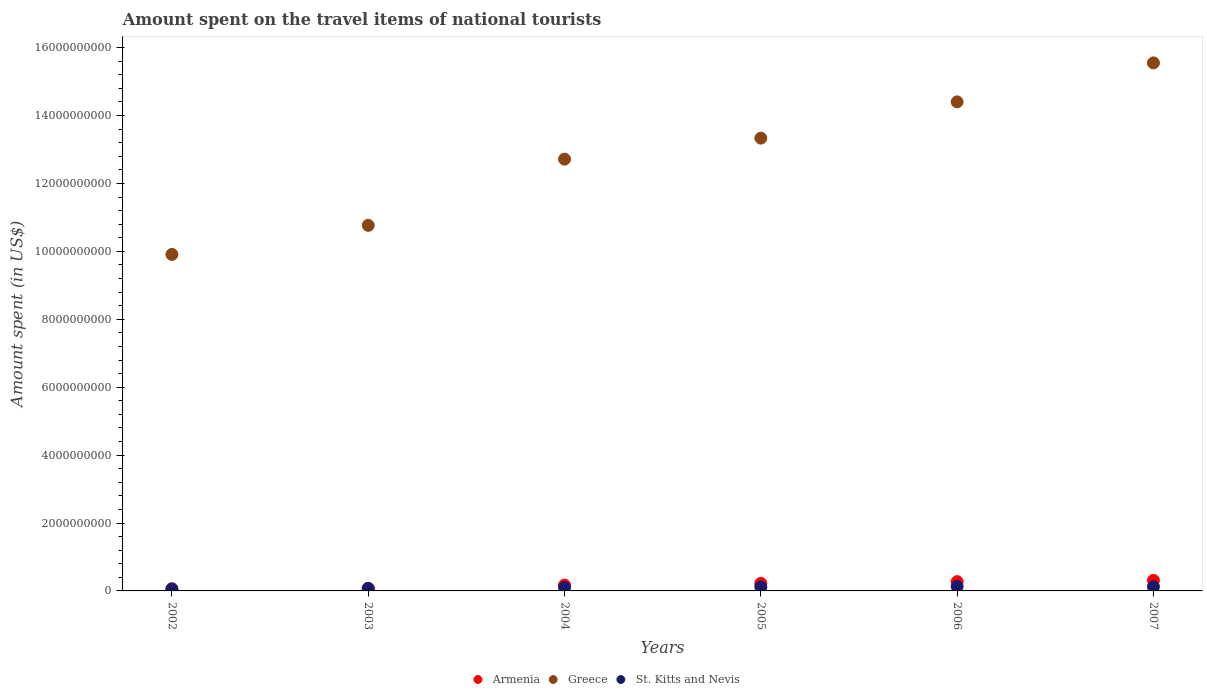How many different coloured dotlines are there?
Offer a very short reply. 3. What is the amount spent on the travel items of national tourists in Armenia in 2003?
Offer a very short reply. 7.30e+07. Across all years, what is the maximum amount spent on the travel items of national tourists in Armenia?
Offer a terse response. 3.11e+08. Across all years, what is the minimum amount spent on the travel items of national tourists in Greece?
Make the answer very short. 9.91e+09. What is the total amount spent on the travel items of national tourists in St. Kitts and Nevis in the graph?
Give a very brief answer. 6.13e+08. What is the difference between the amount spent on the travel items of national tourists in Armenia in 2002 and that in 2003?
Your response must be concise. -1.00e+07. What is the difference between the amount spent on the travel items of national tourists in Armenia in 2003 and the amount spent on the travel items of national tourists in St. Kitts and Nevis in 2007?
Offer a terse response. -5.20e+07. What is the average amount spent on the travel items of national tourists in Armenia per year?
Your answer should be compact. 1.86e+08. In the year 2003, what is the difference between the amount spent on the travel items of national tourists in St. Kitts and Nevis and amount spent on the travel items of national tourists in Armenia?
Provide a short and direct response. 2.00e+06. In how many years, is the amount spent on the travel items of national tourists in Armenia greater than 7600000000 US$?
Keep it short and to the point. 0. What is the ratio of the amount spent on the travel items of national tourists in St. Kitts and Nevis in 2003 to that in 2004?
Give a very brief answer. 0.73. Is the amount spent on the travel items of national tourists in Greece in 2006 less than that in 2007?
Offer a very short reply. Yes. Is the difference between the amount spent on the travel items of national tourists in St. Kitts and Nevis in 2003 and 2006 greater than the difference between the amount spent on the travel items of national tourists in Armenia in 2003 and 2006?
Offer a terse response. Yes. What is the difference between the highest and the second highest amount spent on the travel items of national tourists in Armenia?
Offer a very short reply. 3.80e+07. What is the difference between the highest and the lowest amount spent on the travel items of national tourists in St. Kitts and Nevis?
Give a very brief answer. 7.50e+07. In how many years, is the amount spent on the travel items of national tourists in Greece greater than the average amount spent on the travel items of national tourists in Greece taken over all years?
Provide a short and direct response. 3. Does the amount spent on the travel items of national tourists in St. Kitts and Nevis monotonically increase over the years?
Ensure brevity in your answer.  No. Is the amount spent on the travel items of national tourists in Armenia strictly greater than the amount spent on the travel items of national tourists in Greece over the years?
Offer a terse response. No. How many dotlines are there?
Offer a terse response. 3. What is the difference between two consecutive major ticks on the Y-axis?
Ensure brevity in your answer.  2.00e+09. Are the values on the major ticks of Y-axis written in scientific E-notation?
Offer a very short reply. No. Does the graph contain any zero values?
Your answer should be very brief. No. Does the graph contain grids?
Provide a succinct answer. No. How are the legend labels stacked?
Provide a short and direct response. Horizontal. What is the title of the graph?
Offer a terse response. Amount spent on the travel items of national tourists. Does "Maldives" appear as one of the legend labels in the graph?
Provide a short and direct response. No. What is the label or title of the X-axis?
Your response must be concise. Years. What is the label or title of the Y-axis?
Give a very brief answer. Amount spent (in US$). What is the Amount spent (in US$) in Armenia in 2002?
Keep it short and to the point. 6.30e+07. What is the Amount spent (in US$) in Greece in 2002?
Ensure brevity in your answer.  9.91e+09. What is the Amount spent (in US$) in St. Kitts and Nevis in 2002?
Your answer should be very brief. 5.70e+07. What is the Amount spent (in US$) in Armenia in 2003?
Keep it short and to the point. 7.30e+07. What is the Amount spent (in US$) in Greece in 2003?
Provide a succinct answer. 1.08e+1. What is the Amount spent (in US$) in St. Kitts and Nevis in 2003?
Offer a very short reply. 7.50e+07. What is the Amount spent (in US$) of Armenia in 2004?
Offer a terse response. 1.71e+08. What is the Amount spent (in US$) of Greece in 2004?
Your answer should be very brief. 1.27e+1. What is the Amount spent (in US$) in St. Kitts and Nevis in 2004?
Offer a terse response. 1.03e+08. What is the Amount spent (in US$) of Armenia in 2005?
Your response must be concise. 2.23e+08. What is the Amount spent (in US$) of Greece in 2005?
Provide a short and direct response. 1.33e+1. What is the Amount spent (in US$) in St. Kitts and Nevis in 2005?
Offer a terse response. 1.21e+08. What is the Amount spent (in US$) of Armenia in 2006?
Provide a short and direct response. 2.73e+08. What is the Amount spent (in US$) of Greece in 2006?
Offer a very short reply. 1.44e+1. What is the Amount spent (in US$) of St. Kitts and Nevis in 2006?
Offer a very short reply. 1.32e+08. What is the Amount spent (in US$) in Armenia in 2007?
Offer a terse response. 3.11e+08. What is the Amount spent (in US$) in Greece in 2007?
Your answer should be very brief. 1.56e+1. What is the Amount spent (in US$) in St. Kitts and Nevis in 2007?
Your answer should be compact. 1.25e+08. Across all years, what is the maximum Amount spent (in US$) in Armenia?
Give a very brief answer. 3.11e+08. Across all years, what is the maximum Amount spent (in US$) in Greece?
Give a very brief answer. 1.56e+1. Across all years, what is the maximum Amount spent (in US$) of St. Kitts and Nevis?
Provide a succinct answer. 1.32e+08. Across all years, what is the minimum Amount spent (in US$) of Armenia?
Your response must be concise. 6.30e+07. Across all years, what is the minimum Amount spent (in US$) of Greece?
Offer a terse response. 9.91e+09. Across all years, what is the minimum Amount spent (in US$) in St. Kitts and Nevis?
Offer a terse response. 5.70e+07. What is the total Amount spent (in US$) in Armenia in the graph?
Provide a short and direct response. 1.11e+09. What is the total Amount spent (in US$) of Greece in the graph?
Give a very brief answer. 7.67e+1. What is the total Amount spent (in US$) in St. Kitts and Nevis in the graph?
Your answer should be compact. 6.13e+08. What is the difference between the Amount spent (in US$) of Armenia in 2002 and that in 2003?
Your answer should be very brief. -1.00e+07. What is the difference between the Amount spent (in US$) of Greece in 2002 and that in 2003?
Your answer should be compact. -8.57e+08. What is the difference between the Amount spent (in US$) in St. Kitts and Nevis in 2002 and that in 2003?
Offer a very short reply. -1.80e+07. What is the difference between the Amount spent (in US$) in Armenia in 2002 and that in 2004?
Offer a terse response. -1.08e+08. What is the difference between the Amount spent (in US$) of Greece in 2002 and that in 2004?
Provide a short and direct response. -2.81e+09. What is the difference between the Amount spent (in US$) in St. Kitts and Nevis in 2002 and that in 2004?
Provide a short and direct response. -4.60e+07. What is the difference between the Amount spent (in US$) of Armenia in 2002 and that in 2005?
Your response must be concise. -1.60e+08. What is the difference between the Amount spent (in US$) in Greece in 2002 and that in 2005?
Your answer should be compact. -3.42e+09. What is the difference between the Amount spent (in US$) in St. Kitts and Nevis in 2002 and that in 2005?
Your answer should be compact. -6.40e+07. What is the difference between the Amount spent (in US$) in Armenia in 2002 and that in 2006?
Offer a terse response. -2.10e+08. What is the difference between the Amount spent (in US$) in Greece in 2002 and that in 2006?
Your answer should be compact. -4.49e+09. What is the difference between the Amount spent (in US$) in St. Kitts and Nevis in 2002 and that in 2006?
Your answer should be very brief. -7.50e+07. What is the difference between the Amount spent (in US$) in Armenia in 2002 and that in 2007?
Make the answer very short. -2.48e+08. What is the difference between the Amount spent (in US$) in Greece in 2002 and that in 2007?
Your answer should be compact. -5.64e+09. What is the difference between the Amount spent (in US$) in St. Kitts and Nevis in 2002 and that in 2007?
Your response must be concise. -6.80e+07. What is the difference between the Amount spent (in US$) of Armenia in 2003 and that in 2004?
Make the answer very short. -9.80e+07. What is the difference between the Amount spent (in US$) of Greece in 2003 and that in 2004?
Provide a succinct answer. -1.95e+09. What is the difference between the Amount spent (in US$) in St. Kitts and Nevis in 2003 and that in 2004?
Ensure brevity in your answer.  -2.80e+07. What is the difference between the Amount spent (in US$) in Armenia in 2003 and that in 2005?
Provide a short and direct response. -1.50e+08. What is the difference between the Amount spent (in US$) of Greece in 2003 and that in 2005?
Your response must be concise. -2.57e+09. What is the difference between the Amount spent (in US$) in St. Kitts and Nevis in 2003 and that in 2005?
Your answer should be very brief. -4.60e+07. What is the difference between the Amount spent (in US$) in Armenia in 2003 and that in 2006?
Provide a succinct answer. -2.00e+08. What is the difference between the Amount spent (in US$) in Greece in 2003 and that in 2006?
Make the answer very short. -3.64e+09. What is the difference between the Amount spent (in US$) of St. Kitts and Nevis in 2003 and that in 2006?
Your answer should be compact. -5.70e+07. What is the difference between the Amount spent (in US$) in Armenia in 2003 and that in 2007?
Offer a terse response. -2.38e+08. What is the difference between the Amount spent (in US$) in Greece in 2003 and that in 2007?
Offer a very short reply. -4.78e+09. What is the difference between the Amount spent (in US$) of St. Kitts and Nevis in 2003 and that in 2007?
Ensure brevity in your answer.  -5.00e+07. What is the difference between the Amount spent (in US$) of Armenia in 2004 and that in 2005?
Your answer should be compact. -5.20e+07. What is the difference between the Amount spent (in US$) of Greece in 2004 and that in 2005?
Your answer should be very brief. -6.19e+08. What is the difference between the Amount spent (in US$) in St. Kitts and Nevis in 2004 and that in 2005?
Ensure brevity in your answer.  -1.80e+07. What is the difference between the Amount spent (in US$) of Armenia in 2004 and that in 2006?
Your answer should be compact. -1.02e+08. What is the difference between the Amount spent (in US$) of Greece in 2004 and that in 2006?
Your answer should be very brief. -1.69e+09. What is the difference between the Amount spent (in US$) in St. Kitts and Nevis in 2004 and that in 2006?
Ensure brevity in your answer.  -2.90e+07. What is the difference between the Amount spent (in US$) in Armenia in 2004 and that in 2007?
Keep it short and to the point. -1.40e+08. What is the difference between the Amount spent (in US$) of Greece in 2004 and that in 2007?
Your answer should be compact. -2.84e+09. What is the difference between the Amount spent (in US$) in St. Kitts and Nevis in 2004 and that in 2007?
Provide a succinct answer. -2.20e+07. What is the difference between the Amount spent (in US$) of Armenia in 2005 and that in 2006?
Your answer should be compact. -5.00e+07. What is the difference between the Amount spent (in US$) in Greece in 2005 and that in 2006?
Offer a very short reply. -1.07e+09. What is the difference between the Amount spent (in US$) of St. Kitts and Nevis in 2005 and that in 2006?
Offer a very short reply. -1.10e+07. What is the difference between the Amount spent (in US$) in Armenia in 2005 and that in 2007?
Make the answer very short. -8.80e+07. What is the difference between the Amount spent (in US$) in Greece in 2005 and that in 2007?
Keep it short and to the point. -2.22e+09. What is the difference between the Amount spent (in US$) of St. Kitts and Nevis in 2005 and that in 2007?
Your answer should be very brief. -4.00e+06. What is the difference between the Amount spent (in US$) in Armenia in 2006 and that in 2007?
Provide a succinct answer. -3.80e+07. What is the difference between the Amount spent (in US$) of Greece in 2006 and that in 2007?
Give a very brief answer. -1.15e+09. What is the difference between the Amount spent (in US$) of Armenia in 2002 and the Amount spent (in US$) of Greece in 2003?
Ensure brevity in your answer.  -1.07e+1. What is the difference between the Amount spent (in US$) in Armenia in 2002 and the Amount spent (in US$) in St. Kitts and Nevis in 2003?
Provide a short and direct response. -1.20e+07. What is the difference between the Amount spent (in US$) in Greece in 2002 and the Amount spent (in US$) in St. Kitts and Nevis in 2003?
Make the answer very short. 9.83e+09. What is the difference between the Amount spent (in US$) of Armenia in 2002 and the Amount spent (in US$) of Greece in 2004?
Provide a succinct answer. -1.27e+1. What is the difference between the Amount spent (in US$) in Armenia in 2002 and the Amount spent (in US$) in St. Kitts and Nevis in 2004?
Provide a short and direct response. -4.00e+07. What is the difference between the Amount spent (in US$) in Greece in 2002 and the Amount spent (in US$) in St. Kitts and Nevis in 2004?
Provide a succinct answer. 9.81e+09. What is the difference between the Amount spent (in US$) in Armenia in 2002 and the Amount spent (in US$) in Greece in 2005?
Provide a succinct answer. -1.33e+1. What is the difference between the Amount spent (in US$) in Armenia in 2002 and the Amount spent (in US$) in St. Kitts and Nevis in 2005?
Provide a succinct answer. -5.80e+07. What is the difference between the Amount spent (in US$) of Greece in 2002 and the Amount spent (in US$) of St. Kitts and Nevis in 2005?
Keep it short and to the point. 9.79e+09. What is the difference between the Amount spent (in US$) of Armenia in 2002 and the Amount spent (in US$) of Greece in 2006?
Make the answer very short. -1.43e+1. What is the difference between the Amount spent (in US$) of Armenia in 2002 and the Amount spent (in US$) of St. Kitts and Nevis in 2006?
Your response must be concise. -6.90e+07. What is the difference between the Amount spent (in US$) in Greece in 2002 and the Amount spent (in US$) in St. Kitts and Nevis in 2006?
Your answer should be very brief. 9.78e+09. What is the difference between the Amount spent (in US$) of Armenia in 2002 and the Amount spent (in US$) of Greece in 2007?
Your response must be concise. -1.55e+1. What is the difference between the Amount spent (in US$) of Armenia in 2002 and the Amount spent (in US$) of St. Kitts and Nevis in 2007?
Keep it short and to the point. -6.20e+07. What is the difference between the Amount spent (in US$) of Greece in 2002 and the Amount spent (in US$) of St. Kitts and Nevis in 2007?
Make the answer very short. 9.78e+09. What is the difference between the Amount spent (in US$) of Armenia in 2003 and the Amount spent (in US$) of Greece in 2004?
Keep it short and to the point. -1.26e+1. What is the difference between the Amount spent (in US$) in Armenia in 2003 and the Amount spent (in US$) in St. Kitts and Nevis in 2004?
Your answer should be compact. -3.00e+07. What is the difference between the Amount spent (in US$) of Greece in 2003 and the Amount spent (in US$) of St. Kitts and Nevis in 2004?
Your response must be concise. 1.07e+1. What is the difference between the Amount spent (in US$) of Armenia in 2003 and the Amount spent (in US$) of Greece in 2005?
Keep it short and to the point. -1.33e+1. What is the difference between the Amount spent (in US$) in Armenia in 2003 and the Amount spent (in US$) in St. Kitts and Nevis in 2005?
Offer a very short reply. -4.80e+07. What is the difference between the Amount spent (in US$) in Greece in 2003 and the Amount spent (in US$) in St. Kitts and Nevis in 2005?
Provide a short and direct response. 1.06e+1. What is the difference between the Amount spent (in US$) of Armenia in 2003 and the Amount spent (in US$) of Greece in 2006?
Your answer should be very brief. -1.43e+1. What is the difference between the Amount spent (in US$) in Armenia in 2003 and the Amount spent (in US$) in St. Kitts and Nevis in 2006?
Provide a short and direct response. -5.90e+07. What is the difference between the Amount spent (in US$) of Greece in 2003 and the Amount spent (in US$) of St. Kitts and Nevis in 2006?
Provide a succinct answer. 1.06e+1. What is the difference between the Amount spent (in US$) of Armenia in 2003 and the Amount spent (in US$) of Greece in 2007?
Your answer should be very brief. -1.55e+1. What is the difference between the Amount spent (in US$) in Armenia in 2003 and the Amount spent (in US$) in St. Kitts and Nevis in 2007?
Offer a terse response. -5.20e+07. What is the difference between the Amount spent (in US$) in Greece in 2003 and the Amount spent (in US$) in St. Kitts and Nevis in 2007?
Your response must be concise. 1.06e+1. What is the difference between the Amount spent (in US$) in Armenia in 2004 and the Amount spent (in US$) in Greece in 2005?
Offer a terse response. -1.32e+1. What is the difference between the Amount spent (in US$) of Armenia in 2004 and the Amount spent (in US$) of St. Kitts and Nevis in 2005?
Provide a short and direct response. 5.00e+07. What is the difference between the Amount spent (in US$) in Greece in 2004 and the Amount spent (in US$) in St. Kitts and Nevis in 2005?
Make the answer very short. 1.26e+1. What is the difference between the Amount spent (in US$) in Armenia in 2004 and the Amount spent (in US$) in Greece in 2006?
Provide a short and direct response. -1.42e+1. What is the difference between the Amount spent (in US$) in Armenia in 2004 and the Amount spent (in US$) in St. Kitts and Nevis in 2006?
Keep it short and to the point. 3.90e+07. What is the difference between the Amount spent (in US$) in Greece in 2004 and the Amount spent (in US$) in St. Kitts and Nevis in 2006?
Keep it short and to the point. 1.26e+1. What is the difference between the Amount spent (in US$) in Armenia in 2004 and the Amount spent (in US$) in Greece in 2007?
Keep it short and to the point. -1.54e+1. What is the difference between the Amount spent (in US$) of Armenia in 2004 and the Amount spent (in US$) of St. Kitts and Nevis in 2007?
Keep it short and to the point. 4.60e+07. What is the difference between the Amount spent (in US$) of Greece in 2004 and the Amount spent (in US$) of St. Kitts and Nevis in 2007?
Give a very brief answer. 1.26e+1. What is the difference between the Amount spent (in US$) of Armenia in 2005 and the Amount spent (in US$) of Greece in 2006?
Ensure brevity in your answer.  -1.42e+1. What is the difference between the Amount spent (in US$) in Armenia in 2005 and the Amount spent (in US$) in St. Kitts and Nevis in 2006?
Your answer should be very brief. 9.10e+07. What is the difference between the Amount spent (in US$) in Greece in 2005 and the Amount spent (in US$) in St. Kitts and Nevis in 2006?
Your answer should be compact. 1.32e+1. What is the difference between the Amount spent (in US$) in Armenia in 2005 and the Amount spent (in US$) in Greece in 2007?
Keep it short and to the point. -1.53e+1. What is the difference between the Amount spent (in US$) in Armenia in 2005 and the Amount spent (in US$) in St. Kitts and Nevis in 2007?
Your answer should be very brief. 9.80e+07. What is the difference between the Amount spent (in US$) of Greece in 2005 and the Amount spent (in US$) of St. Kitts and Nevis in 2007?
Provide a succinct answer. 1.32e+1. What is the difference between the Amount spent (in US$) of Armenia in 2006 and the Amount spent (in US$) of Greece in 2007?
Your response must be concise. -1.53e+1. What is the difference between the Amount spent (in US$) of Armenia in 2006 and the Amount spent (in US$) of St. Kitts and Nevis in 2007?
Offer a very short reply. 1.48e+08. What is the difference between the Amount spent (in US$) in Greece in 2006 and the Amount spent (in US$) in St. Kitts and Nevis in 2007?
Make the answer very short. 1.43e+1. What is the average Amount spent (in US$) of Armenia per year?
Your response must be concise. 1.86e+08. What is the average Amount spent (in US$) of Greece per year?
Your answer should be very brief. 1.28e+1. What is the average Amount spent (in US$) of St. Kitts and Nevis per year?
Keep it short and to the point. 1.02e+08. In the year 2002, what is the difference between the Amount spent (in US$) of Armenia and Amount spent (in US$) of Greece?
Your answer should be compact. -9.85e+09. In the year 2002, what is the difference between the Amount spent (in US$) in Greece and Amount spent (in US$) in St. Kitts and Nevis?
Your answer should be compact. 9.85e+09. In the year 2003, what is the difference between the Amount spent (in US$) in Armenia and Amount spent (in US$) in Greece?
Make the answer very short. -1.07e+1. In the year 2003, what is the difference between the Amount spent (in US$) in Greece and Amount spent (in US$) in St. Kitts and Nevis?
Your answer should be compact. 1.07e+1. In the year 2004, what is the difference between the Amount spent (in US$) in Armenia and Amount spent (in US$) in Greece?
Make the answer very short. -1.25e+1. In the year 2004, what is the difference between the Amount spent (in US$) in Armenia and Amount spent (in US$) in St. Kitts and Nevis?
Ensure brevity in your answer.  6.80e+07. In the year 2004, what is the difference between the Amount spent (in US$) of Greece and Amount spent (in US$) of St. Kitts and Nevis?
Make the answer very short. 1.26e+1. In the year 2005, what is the difference between the Amount spent (in US$) in Armenia and Amount spent (in US$) in Greece?
Make the answer very short. -1.31e+1. In the year 2005, what is the difference between the Amount spent (in US$) in Armenia and Amount spent (in US$) in St. Kitts and Nevis?
Your answer should be very brief. 1.02e+08. In the year 2005, what is the difference between the Amount spent (in US$) in Greece and Amount spent (in US$) in St. Kitts and Nevis?
Offer a very short reply. 1.32e+1. In the year 2006, what is the difference between the Amount spent (in US$) in Armenia and Amount spent (in US$) in Greece?
Make the answer very short. -1.41e+1. In the year 2006, what is the difference between the Amount spent (in US$) in Armenia and Amount spent (in US$) in St. Kitts and Nevis?
Your answer should be very brief. 1.41e+08. In the year 2006, what is the difference between the Amount spent (in US$) in Greece and Amount spent (in US$) in St. Kitts and Nevis?
Offer a terse response. 1.43e+1. In the year 2007, what is the difference between the Amount spent (in US$) of Armenia and Amount spent (in US$) of Greece?
Provide a succinct answer. -1.52e+1. In the year 2007, what is the difference between the Amount spent (in US$) of Armenia and Amount spent (in US$) of St. Kitts and Nevis?
Give a very brief answer. 1.86e+08. In the year 2007, what is the difference between the Amount spent (in US$) in Greece and Amount spent (in US$) in St. Kitts and Nevis?
Your response must be concise. 1.54e+1. What is the ratio of the Amount spent (in US$) of Armenia in 2002 to that in 2003?
Your answer should be compact. 0.86. What is the ratio of the Amount spent (in US$) in Greece in 2002 to that in 2003?
Provide a short and direct response. 0.92. What is the ratio of the Amount spent (in US$) of St. Kitts and Nevis in 2002 to that in 2003?
Give a very brief answer. 0.76. What is the ratio of the Amount spent (in US$) in Armenia in 2002 to that in 2004?
Provide a succinct answer. 0.37. What is the ratio of the Amount spent (in US$) of Greece in 2002 to that in 2004?
Make the answer very short. 0.78. What is the ratio of the Amount spent (in US$) in St. Kitts and Nevis in 2002 to that in 2004?
Your response must be concise. 0.55. What is the ratio of the Amount spent (in US$) in Armenia in 2002 to that in 2005?
Your response must be concise. 0.28. What is the ratio of the Amount spent (in US$) of Greece in 2002 to that in 2005?
Your answer should be compact. 0.74. What is the ratio of the Amount spent (in US$) in St. Kitts and Nevis in 2002 to that in 2005?
Your answer should be compact. 0.47. What is the ratio of the Amount spent (in US$) in Armenia in 2002 to that in 2006?
Provide a succinct answer. 0.23. What is the ratio of the Amount spent (in US$) of Greece in 2002 to that in 2006?
Your answer should be very brief. 0.69. What is the ratio of the Amount spent (in US$) of St. Kitts and Nevis in 2002 to that in 2006?
Ensure brevity in your answer.  0.43. What is the ratio of the Amount spent (in US$) in Armenia in 2002 to that in 2007?
Ensure brevity in your answer.  0.2. What is the ratio of the Amount spent (in US$) of Greece in 2002 to that in 2007?
Give a very brief answer. 0.64. What is the ratio of the Amount spent (in US$) of St. Kitts and Nevis in 2002 to that in 2007?
Offer a very short reply. 0.46. What is the ratio of the Amount spent (in US$) in Armenia in 2003 to that in 2004?
Give a very brief answer. 0.43. What is the ratio of the Amount spent (in US$) in Greece in 2003 to that in 2004?
Offer a very short reply. 0.85. What is the ratio of the Amount spent (in US$) of St. Kitts and Nevis in 2003 to that in 2004?
Offer a terse response. 0.73. What is the ratio of the Amount spent (in US$) of Armenia in 2003 to that in 2005?
Give a very brief answer. 0.33. What is the ratio of the Amount spent (in US$) of Greece in 2003 to that in 2005?
Make the answer very short. 0.81. What is the ratio of the Amount spent (in US$) of St. Kitts and Nevis in 2003 to that in 2005?
Provide a short and direct response. 0.62. What is the ratio of the Amount spent (in US$) in Armenia in 2003 to that in 2006?
Your answer should be compact. 0.27. What is the ratio of the Amount spent (in US$) of Greece in 2003 to that in 2006?
Offer a very short reply. 0.75. What is the ratio of the Amount spent (in US$) of St. Kitts and Nevis in 2003 to that in 2006?
Make the answer very short. 0.57. What is the ratio of the Amount spent (in US$) in Armenia in 2003 to that in 2007?
Provide a short and direct response. 0.23. What is the ratio of the Amount spent (in US$) of Greece in 2003 to that in 2007?
Provide a succinct answer. 0.69. What is the ratio of the Amount spent (in US$) of St. Kitts and Nevis in 2003 to that in 2007?
Ensure brevity in your answer.  0.6. What is the ratio of the Amount spent (in US$) in Armenia in 2004 to that in 2005?
Your answer should be very brief. 0.77. What is the ratio of the Amount spent (in US$) of Greece in 2004 to that in 2005?
Your answer should be compact. 0.95. What is the ratio of the Amount spent (in US$) of St. Kitts and Nevis in 2004 to that in 2005?
Ensure brevity in your answer.  0.85. What is the ratio of the Amount spent (in US$) in Armenia in 2004 to that in 2006?
Your answer should be very brief. 0.63. What is the ratio of the Amount spent (in US$) of Greece in 2004 to that in 2006?
Offer a terse response. 0.88. What is the ratio of the Amount spent (in US$) in St. Kitts and Nevis in 2004 to that in 2006?
Your answer should be very brief. 0.78. What is the ratio of the Amount spent (in US$) of Armenia in 2004 to that in 2007?
Provide a short and direct response. 0.55. What is the ratio of the Amount spent (in US$) of Greece in 2004 to that in 2007?
Provide a succinct answer. 0.82. What is the ratio of the Amount spent (in US$) of St. Kitts and Nevis in 2004 to that in 2007?
Make the answer very short. 0.82. What is the ratio of the Amount spent (in US$) in Armenia in 2005 to that in 2006?
Ensure brevity in your answer.  0.82. What is the ratio of the Amount spent (in US$) of Greece in 2005 to that in 2006?
Keep it short and to the point. 0.93. What is the ratio of the Amount spent (in US$) of Armenia in 2005 to that in 2007?
Offer a terse response. 0.72. What is the ratio of the Amount spent (in US$) of Greece in 2005 to that in 2007?
Keep it short and to the point. 0.86. What is the ratio of the Amount spent (in US$) of St. Kitts and Nevis in 2005 to that in 2007?
Your response must be concise. 0.97. What is the ratio of the Amount spent (in US$) in Armenia in 2006 to that in 2007?
Make the answer very short. 0.88. What is the ratio of the Amount spent (in US$) in Greece in 2006 to that in 2007?
Offer a terse response. 0.93. What is the ratio of the Amount spent (in US$) of St. Kitts and Nevis in 2006 to that in 2007?
Ensure brevity in your answer.  1.06. What is the difference between the highest and the second highest Amount spent (in US$) of Armenia?
Your answer should be compact. 3.80e+07. What is the difference between the highest and the second highest Amount spent (in US$) in Greece?
Ensure brevity in your answer.  1.15e+09. What is the difference between the highest and the second highest Amount spent (in US$) in St. Kitts and Nevis?
Provide a succinct answer. 7.00e+06. What is the difference between the highest and the lowest Amount spent (in US$) in Armenia?
Make the answer very short. 2.48e+08. What is the difference between the highest and the lowest Amount spent (in US$) in Greece?
Offer a very short reply. 5.64e+09. What is the difference between the highest and the lowest Amount spent (in US$) of St. Kitts and Nevis?
Your answer should be compact. 7.50e+07. 